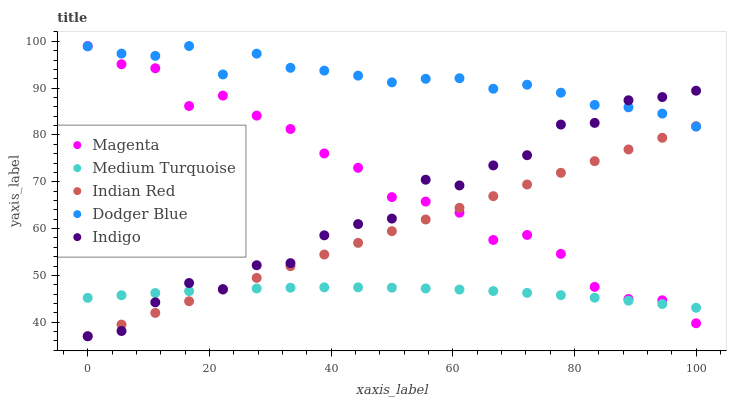Does Medium Turquoise have the minimum area under the curve?
Answer yes or no. Yes. Does Dodger Blue have the maximum area under the curve?
Answer yes or no. Yes. Does Magenta have the minimum area under the curve?
Answer yes or no. No. Does Magenta have the maximum area under the curve?
Answer yes or no. No. Is Indian Red the smoothest?
Answer yes or no. Yes. Is Indigo the roughest?
Answer yes or no. Yes. Is Magenta the smoothest?
Answer yes or no. No. Is Magenta the roughest?
Answer yes or no. No. Does Indigo have the lowest value?
Answer yes or no. Yes. Does Magenta have the lowest value?
Answer yes or no. No. Does Dodger Blue have the highest value?
Answer yes or no. Yes. Does Indian Red have the highest value?
Answer yes or no. No. Is Medium Turquoise less than Dodger Blue?
Answer yes or no. Yes. Is Dodger Blue greater than Medium Turquoise?
Answer yes or no. Yes. Does Indian Red intersect Indigo?
Answer yes or no. Yes. Is Indian Red less than Indigo?
Answer yes or no. No. Is Indian Red greater than Indigo?
Answer yes or no. No. Does Medium Turquoise intersect Dodger Blue?
Answer yes or no. No. 